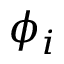Convert formula to latex. <formula><loc_0><loc_0><loc_500><loc_500>\phi _ { i }</formula> 